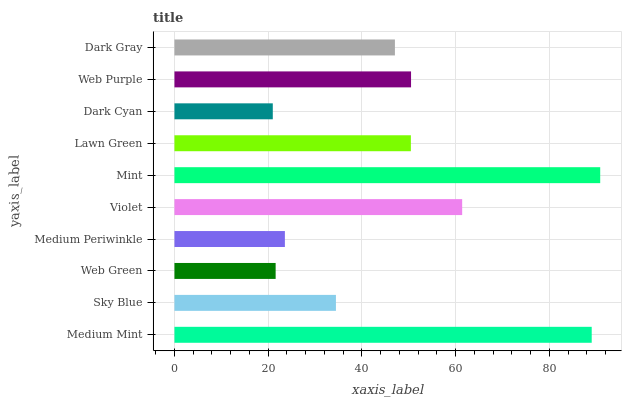Is Dark Cyan the minimum?
Answer yes or no. Yes. Is Mint the maximum?
Answer yes or no. Yes. Is Sky Blue the minimum?
Answer yes or no. No. Is Sky Blue the maximum?
Answer yes or no. No. Is Medium Mint greater than Sky Blue?
Answer yes or no. Yes. Is Sky Blue less than Medium Mint?
Answer yes or no. Yes. Is Sky Blue greater than Medium Mint?
Answer yes or no. No. Is Medium Mint less than Sky Blue?
Answer yes or no. No. Is Lawn Green the high median?
Answer yes or no. Yes. Is Dark Gray the low median?
Answer yes or no. Yes. Is Mint the high median?
Answer yes or no. No. Is Medium Periwinkle the low median?
Answer yes or no. No. 